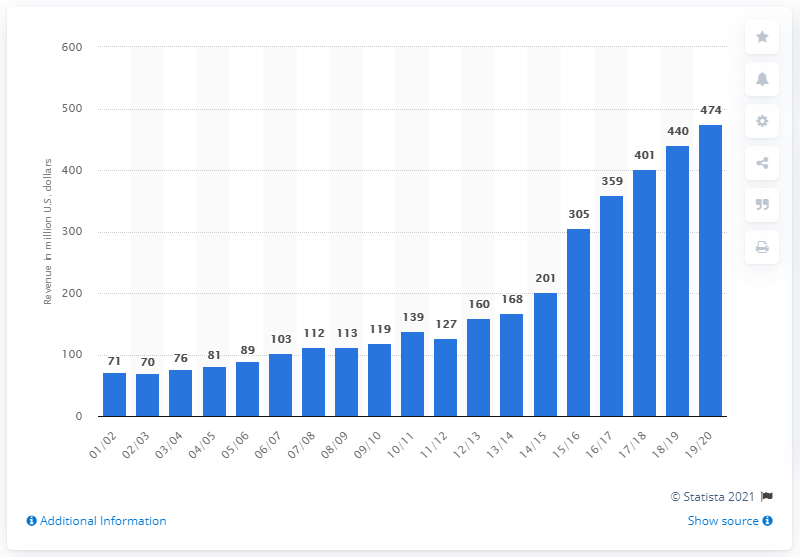Specify some key components in this picture. The estimated revenue of the Golden State Warriors for the 2019/2020 season is approximately 474 million dollars. 